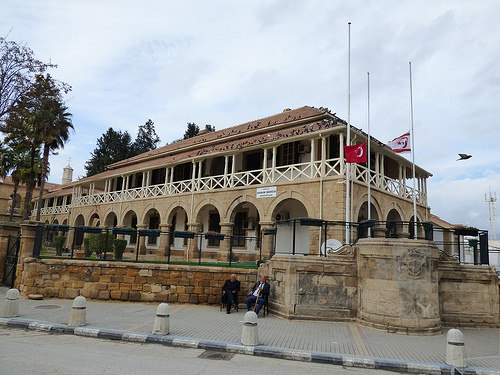<image>
Is there a man on the building? No. The man is not positioned on the building. They may be near each other, but the man is not supported by or resting on top of the building. 